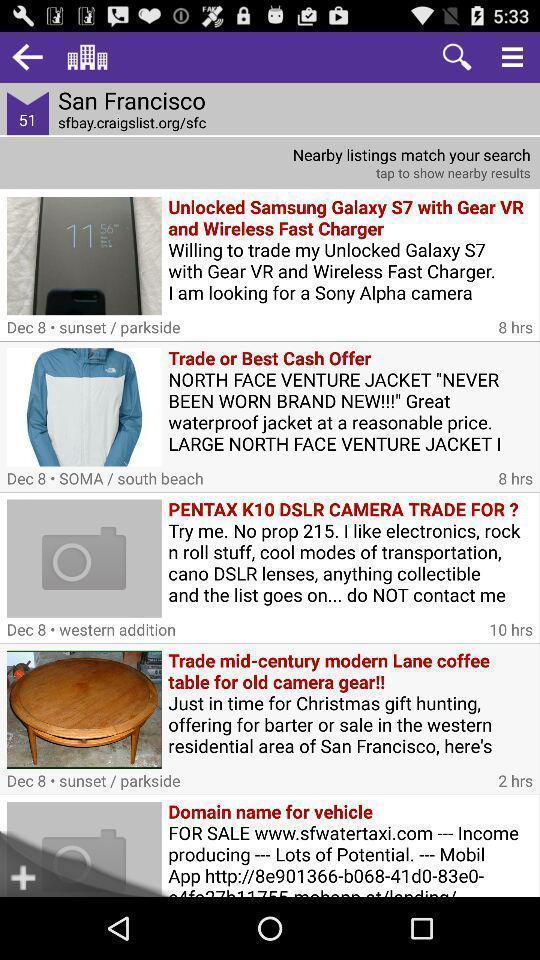Explain the elements present in this screenshot. Results match in search of san francisco. 